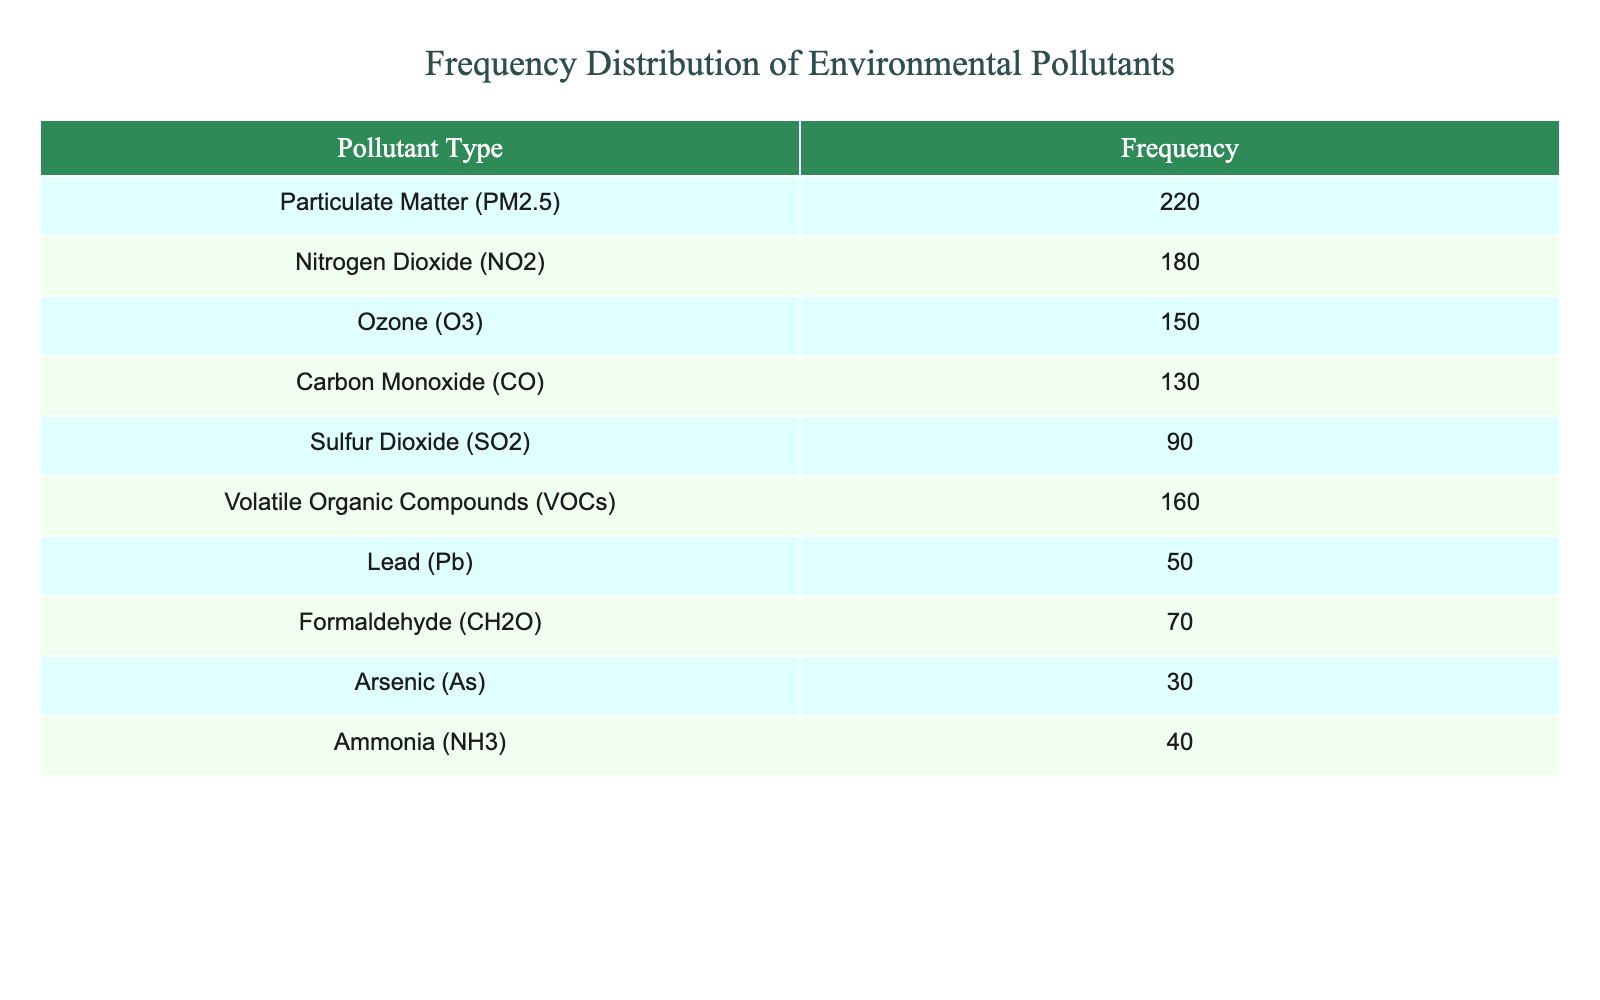What is the most frequently detected pollutant type? The table lists the frequencies of each pollutant type, and by looking down the Frequency column, we can see that Particulate Matter (PM2.5) has the highest frequency at 220.
Answer: Particulate Matter (PM2.5) What is the frequency of Sulfur Dioxide (SO2)? The frequency for Sulfur Dioxide (SO2) is directly stated in the table under the Frequency column, which shows a value of 90.
Answer: 90 How many pollutants have a frequency greater than 100? We need to count the pollutants in the Frequency column that have values greater than 100. The pollutants that meet this criterion are: Particulate Matter (PM2.5), Nitrogen Dioxide (NO2), Ozone (O3), Volatile Organic Compounds (VOCs), and Carbon Monoxide (CO). This totals 5 pollutants.
Answer: 5 Is the frequency of Lead (Pb) more than that of Ammonia (NH3)? The frequency for Lead (Pb) is 50, and the frequency for Ammonia (NH3) is 40. Since 50 is greater than 40, the statement is true.
Answer: Yes What is the sum of the frequencies of Nitrogen Dioxide (NO2) and Ozone (O3)? The frequency of Nitrogen Dioxide (NO2) is 180 and Ozone (O3) is 150. Adding these two values together gives us: 180 + 150 = 330.
Answer: 330 What is the average frequency of all pollutants listed? To find the average frequency, first we sum all the frequencies: 220 + 180 + 150 + 130 + 90 + 160 + 50 + 70 + 30 + 40 = 1110. Then, because there are 10 pollutants, we divide the total by 10: 1110 / 10 = 111.
Answer: 111 Which pollutant has the lowest detection frequency? From the table, Arsenic (As) has the lowest frequency at 30, which can be observed by scanning the Frequency column for the smallest number.
Answer: Arsenic (As) Is the frequency of Volatile Organic Compounds (VOCs) lower than 100? The frequency of Volatile Organic Compounds (VOCs) is indicated as 160 in the table, which is higher than 100, making the statement false.
Answer: No 